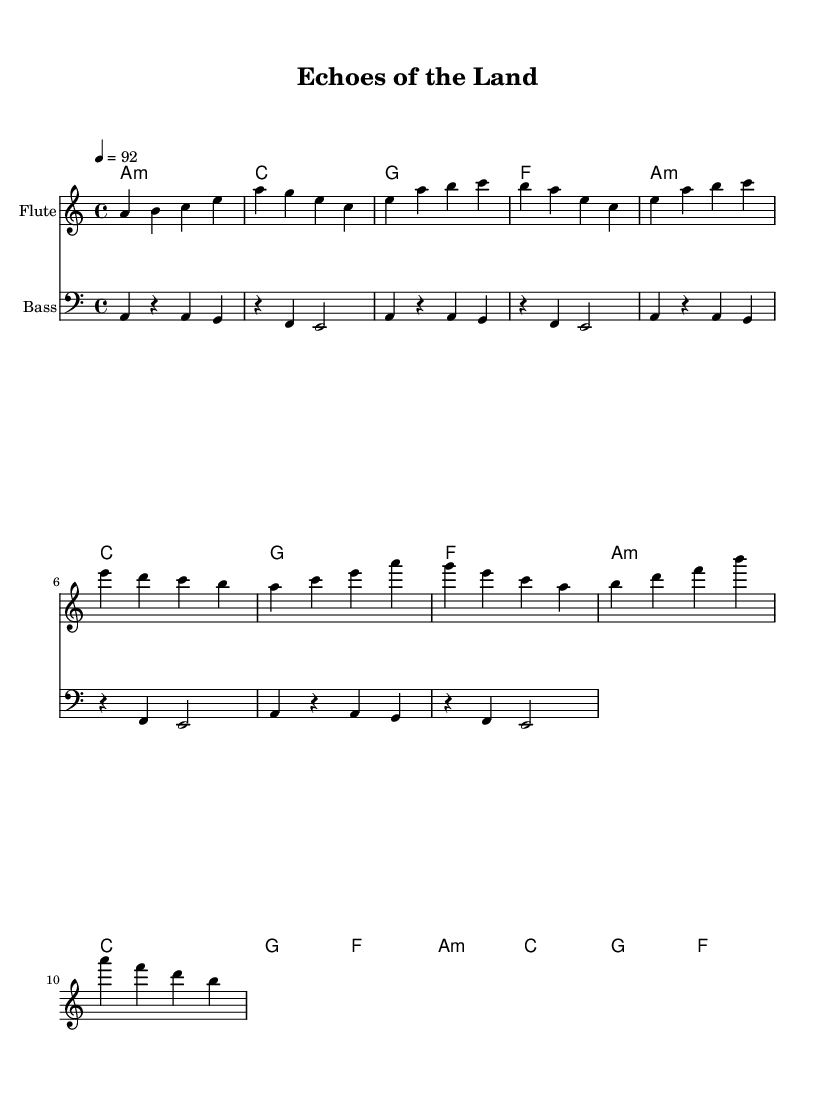What is the key signature of this music? The key signature is A minor, which has no sharps or flats, as indicated at the beginning of the score.
Answer: A minor What is the time signature of this music? The time signature is 4/4, which is noted at the beginning of the score and indicates that there are four beats in each measure.
Answer: 4/4 What is the tempo marking for this music? The tempo marking is "4 = 92," which indicates that there are 92 beats per minute, providing the speed of the music.
Answer: 92 How many measures are in the flute part? The flute part consists of 12 measures, as counted from the intro through the verse and chorus sections combined.
Answer: 12 What is the first note of the flute part? The first note of the flute part is A, which appears in the intro of the music.
Answer: A Which chord appears most frequently in the chord progression? The chord that appears most frequently is A minor, as it is repeated four times in the chord progression.
Answer: A minor What is the instrument listed for the second staff? The second staff is designated for the "Bass," which is specified at the beginning of the staff.
Answer: Bass 